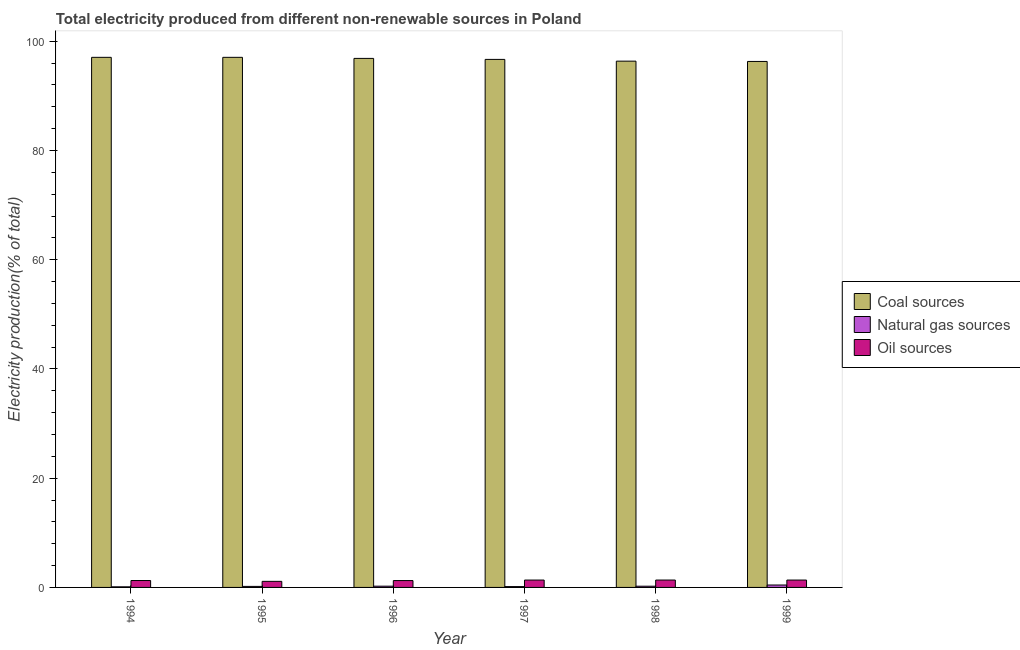How many different coloured bars are there?
Keep it short and to the point. 3. How many bars are there on the 2nd tick from the left?
Your answer should be compact. 3. How many bars are there on the 5th tick from the right?
Offer a terse response. 3. What is the label of the 5th group of bars from the left?
Offer a very short reply. 1998. What is the percentage of electricity produced by natural gas in 1998?
Your answer should be very brief. 0.22. Across all years, what is the maximum percentage of electricity produced by coal?
Give a very brief answer. 97.06. Across all years, what is the minimum percentage of electricity produced by coal?
Keep it short and to the point. 96.3. In which year was the percentage of electricity produced by coal minimum?
Your answer should be very brief. 1999. What is the total percentage of electricity produced by coal in the graph?
Provide a short and direct response. 580.32. What is the difference between the percentage of electricity produced by natural gas in 1995 and that in 1998?
Make the answer very short. -0.03. What is the difference between the percentage of electricity produced by oil sources in 1999 and the percentage of electricity produced by coal in 1998?
Provide a short and direct response. -0. What is the average percentage of electricity produced by natural gas per year?
Provide a short and direct response. 0.22. In the year 1997, what is the difference between the percentage of electricity produced by natural gas and percentage of electricity produced by oil sources?
Offer a very short reply. 0. In how many years, is the percentage of electricity produced by natural gas greater than 92 %?
Your response must be concise. 0. What is the ratio of the percentage of electricity produced by oil sources in 1994 to that in 1997?
Ensure brevity in your answer.  0.94. What is the difference between the highest and the second highest percentage of electricity produced by coal?
Make the answer very short. 0. What is the difference between the highest and the lowest percentage of electricity produced by oil sources?
Provide a short and direct response. 0.24. What does the 1st bar from the left in 1998 represents?
Provide a short and direct response. Coal sources. What does the 1st bar from the right in 1995 represents?
Give a very brief answer. Oil sources. Is it the case that in every year, the sum of the percentage of electricity produced by coal and percentage of electricity produced by natural gas is greater than the percentage of electricity produced by oil sources?
Make the answer very short. Yes. Are the values on the major ticks of Y-axis written in scientific E-notation?
Your response must be concise. No. Where does the legend appear in the graph?
Give a very brief answer. Center right. How are the legend labels stacked?
Your answer should be very brief. Vertical. What is the title of the graph?
Provide a succinct answer. Total electricity produced from different non-renewable sources in Poland. Does "Unemployment benefits" appear as one of the legend labels in the graph?
Make the answer very short. No. What is the label or title of the X-axis?
Offer a very short reply. Year. What is the Electricity production(% of total) in Coal sources in 1994?
Offer a very short reply. 97.06. What is the Electricity production(% of total) of Natural gas sources in 1994?
Ensure brevity in your answer.  0.11. What is the Electricity production(% of total) in Oil sources in 1994?
Provide a succinct answer. 1.26. What is the Electricity production(% of total) of Coal sources in 1995?
Offer a very short reply. 97.06. What is the Electricity production(% of total) in Natural gas sources in 1995?
Your answer should be compact. 0.19. What is the Electricity production(% of total) of Oil sources in 1995?
Your response must be concise. 1.11. What is the Electricity production(% of total) of Coal sources in 1996?
Your response must be concise. 96.86. What is the Electricity production(% of total) of Natural gas sources in 1996?
Your answer should be very brief. 0.23. What is the Electricity production(% of total) of Oil sources in 1996?
Your response must be concise. 1.26. What is the Electricity production(% of total) in Coal sources in 1997?
Offer a very short reply. 96.68. What is the Electricity production(% of total) in Natural gas sources in 1997?
Your response must be concise. 0.15. What is the Electricity production(% of total) in Oil sources in 1997?
Your response must be concise. 1.35. What is the Electricity production(% of total) of Coal sources in 1998?
Offer a terse response. 96.36. What is the Electricity production(% of total) in Natural gas sources in 1998?
Your response must be concise. 0.22. What is the Electricity production(% of total) in Oil sources in 1998?
Provide a succinct answer. 1.35. What is the Electricity production(% of total) in Coal sources in 1999?
Keep it short and to the point. 96.3. What is the Electricity production(% of total) of Natural gas sources in 1999?
Your response must be concise. 0.44. What is the Electricity production(% of total) of Oil sources in 1999?
Your answer should be compact. 1.35. Across all years, what is the maximum Electricity production(% of total) of Coal sources?
Provide a succinct answer. 97.06. Across all years, what is the maximum Electricity production(% of total) in Natural gas sources?
Give a very brief answer. 0.44. Across all years, what is the maximum Electricity production(% of total) of Oil sources?
Give a very brief answer. 1.35. Across all years, what is the minimum Electricity production(% of total) of Coal sources?
Provide a succinct answer. 96.3. Across all years, what is the minimum Electricity production(% of total) of Natural gas sources?
Offer a very short reply. 0.11. Across all years, what is the minimum Electricity production(% of total) in Oil sources?
Make the answer very short. 1.11. What is the total Electricity production(% of total) in Coal sources in the graph?
Keep it short and to the point. 580.32. What is the total Electricity production(% of total) of Natural gas sources in the graph?
Your response must be concise. 1.35. What is the total Electricity production(% of total) in Oil sources in the graph?
Your response must be concise. 7.68. What is the difference between the Electricity production(% of total) in Coal sources in 1994 and that in 1995?
Your answer should be compact. -0. What is the difference between the Electricity production(% of total) in Natural gas sources in 1994 and that in 1995?
Keep it short and to the point. -0.08. What is the difference between the Electricity production(% of total) in Oil sources in 1994 and that in 1995?
Offer a very short reply. 0.15. What is the difference between the Electricity production(% of total) in Coal sources in 1994 and that in 1996?
Your response must be concise. 0.19. What is the difference between the Electricity production(% of total) in Natural gas sources in 1994 and that in 1996?
Offer a very short reply. -0.12. What is the difference between the Electricity production(% of total) in Oil sources in 1994 and that in 1996?
Your response must be concise. 0.01. What is the difference between the Electricity production(% of total) in Coal sources in 1994 and that in 1997?
Offer a very short reply. 0.38. What is the difference between the Electricity production(% of total) in Natural gas sources in 1994 and that in 1997?
Ensure brevity in your answer.  -0.04. What is the difference between the Electricity production(% of total) in Oil sources in 1994 and that in 1997?
Your answer should be compact. -0.08. What is the difference between the Electricity production(% of total) of Coal sources in 1994 and that in 1998?
Your answer should be very brief. 0.7. What is the difference between the Electricity production(% of total) in Natural gas sources in 1994 and that in 1998?
Provide a succinct answer. -0.11. What is the difference between the Electricity production(% of total) of Oil sources in 1994 and that in 1998?
Your answer should be compact. -0.09. What is the difference between the Electricity production(% of total) of Coal sources in 1994 and that in 1999?
Your response must be concise. 0.75. What is the difference between the Electricity production(% of total) of Natural gas sources in 1994 and that in 1999?
Ensure brevity in your answer.  -0.33. What is the difference between the Electricity production(% of total) in Oil sources in 1994 and that in 1999?
Offer a very short reply. -0.09. What is the difference between the Electricity production(% of total) of Coal sources in 1995 and that in 1996?
Your response must be concise. 0.19. What is the difference between the Electricity production(% of total) of Natural gas sources in 1995 and that in 1996?
Offer a terse response. -0.04. What is the difference between the Electricity production(% of total) in Oil sources in 1995 and that in 1996?
Provide a short and direct response. -0.14. What is the difference between the Electricity production(% of total) in Coal sources in 1995 and that in 1997?
Your answer should be very brief. 0.38. What is the difference between the Electricity production(% of total) in Natural gas sources in 1995 and that in 1997?
Keep it short and to the point. 0.04. What is the difference between the Electricity production(% of total) of Oil sources in 1995 and that in 1997?
Provide a short and direct response. -0.24. What is the difference between the Electricity production(% of total) in Coal sources in 1995 and that in 1998?
Offer a terse response. 0.7. What is the difference between the Electricity production(% of total) in Natural gas sources in 1995 and that in 1998?
Keep it short and to the point. -0.03. What is the difference between the Electricity production(% of total) of Oil sources in 1995 and that in 1998?
Your response must be concise. -0.24. What is the difference between the Electricity production(% of total) of Coal sources in 1995 and that in 1999?
Provide a succinct answer. 0.75. What is the difference between the Electricity production(% of total) in Natural gas sources in 1995 and that in 1999?
Your answer should be compact. -0.25. What is the difference between the Electricity production(% of total) in Oil sources in 1995 and that in 1999?
Offer a very short reply. -0.24. What is the difference between the Electricity production(% of total) of Coal sources in 1996 and that in 1997?
Provide a short and direct response. 0.18. What is the difference between the Electricity production(% of total) of Natural gas sources in 1996 and that in 1997?
Ensure brevity in your answer.  0.08. What is the difference between the Electricity production(% of total) of Oil sources in 1996 and that in 1997?
Provide a succinct answer. -0.09. What is the difference between the Electricity production(% of total) of Coal sources in 1996 and that in 1998?
Keep it short and to the point. 0.5. What is the difference between the Electricity production(% of total) in Natural gas sources in 1996 and that in 1998?
Your response must be concise. 0.01. What is the difference between the Electricity production(% of total) in Oil sources in 1996 and that in 1998?
Make the answer very short. -0.1. What is the difference between the Electricity production(% of total) in Coal sources in 1996 and that in 1999?
Ensure brevity in your answer.  0.56. What is the difference between the Electricity production(% of total) in Natural gas sources in 1996 and that in 1999?
Offer a terse response. -0.21. What is the difference between the Electricity production(% of total) in Oil sources in 1996 and that in 1999?
Give a very brief answer. -0.1. What is the difference between the Electricity production(% of total) of Coal sources in 1997 and that in 1998?
Make the answer very short. 0.32. What is the difference between the Electricity production(% of total) in Natural gas sources in 1997 and that in 1998?
Ensure brevity in your answer.  -0.07. What is the difference between the Electricity production(% of total) in Oil sources in 1997 and that in 1998?
Your answer should be compact. -0. What is the difference between the Electricity production(% of total) in Natural gas sources in 1997 and that in 1999?
Your answer should be very brief. -0.29. What is the difference between the Electricity production(% of total) of Oil sources in 1997 and that in 1999?
Offer a very short reply. -0. What is the difference between the Electricity production(% of total) of Coal sources in 1998 and that in 1999?
Keep it short and to the point. 0.06. What is the difference between the Electricity production(% of total) of Natural gas sources in 1998 and that in 1999?
Provide a short and direct response. -0.22. What is the difference between the Electricity production(% of total) in Oil sources in 1998 and that in 1999?
Keep it short and to the point. 0. What is the difference between the Electricity production(% of total) in Coal sources in 1994 and the Electricity production(% of total) in Natural gas sources in 1995?
Your response must be concise. 96.87. What is the difference between the Electricity production(% of total) in Coal sources in 1994 and the Electricity production(% of total) in Oil sources in 1995?
Offer a terse response. 95.95. What is the difference between the Electricity production(% of total) of Natural gas sources in 1994 and the Electricity production(% of total) of Oil sources in 1995?
Your answer should be very brief. -1. What is the difference between the Electricity production(% of total) in Coal sources in 1994 and the Electricity production(% of total) in Natural gas sources in 1996?
Offer a terse response. 96.83. What is the difference between the Electricity production(% of total) in Coal sources in 1994 and the Electricity production(% of total) in Oil sources in 1996?
Offer a very short reply. 95.8. What is the difference between the Electricity production(% of total) of Natural gas sources in 1994 and the Electricity production(% of total) of Oil sources in 1996?
Your response must be concise. -1.14. What is the difference between the Electricity production(% of total) in Coal sources in 1994 and the Electricity production(% of total) in Natural gas sources in 1997?
Your answer should be compact. 96.9. What is the difference between the Electricity production(% of total) in Coal sources in 1994 and the Electricity production(% of total) in Oil sources in 1997?
Provide a short and direct response. 95.71. What is the difference between the Electricity production(% of total) in Natural gas sources in 1994 and the Electricity production(% of total) in Oil sources in 1997?
Offer a very short reply. -1.24. What is the difference between the Electricity production(% of total) in Coal sources in 1994 and the Electricity production(% of total) in Natural gas sources in 1998?
Ensure brevity in your answer.  96.83. What is the difference between the Electricity production(% of total) in Coal sources in 1994 and the Electricity production(% of total) in Oil sources in 1998?
Give a very brief answer. 95.71. What is the difference between the Electricity production(% of total) of Natural gas sources in 1994 and the Electricity production(% of total) of Oil sources in 1998?
Offer a terse response. -1.24. What is the difference between the Electricity production(% of total) of Coal sources in 1994 and the Electricity production(% of total) of Natural gas sources in 1999?
Your response must be concise. 96.61. What is the difference between the Electricity production(% of total) in Coal sources in 1994 and the Electricity production(% of total) in Oil sources in 1999?
Your answer should be very brief. 95.71. What is the difference between the Electricity production(% of total) in Natural gas sources in 1994 and the Electricity production(% of total) in Oil sources in 1999?
Offer a terse response. -1.24. What is the difference between the Electricity production(% of total) in Coal sources in 1995 and the Electricity production(% of total) in Natural gas sources in 1996?
Make the answer very short. 96.83. What is the difference between the Electricity production(% of total) in Coal sources in 1995 and the Electricity production(% of total) in Oil sources in 1996?
Your answer should be compact. 95.8. What is the difference between the Electricity production(% of total) in Natural gas sources in 1995 and the Electricity production(% of total) in Oil sources in 1996?
Offer a terse response. -1.07. What is the difference between the Electricity production(% of total) in Coal sources in 1995 and the Electricity production(% of total) in Natural gas sources in 1997?
Keep it short and to the point. 96.9. What is the difference between the Electricity production(% of total) in Coal sources in 1995 and the Electricity production(% of total) in Oil sources in 1997?
Make the answer very short. 95.71. What is the difference between the Electricity production(% of total) in Natural gas sources in 1995 and the Electricity production(% of total) in Oil sources in 1997?
Ensure brevity in your answer.  -1.16. What is the difference between the Electricity production(% of total) in Coal sources in 1995 and the Electricity production(% of total) in Natural gas sources in 1998?
Keep it short and to the point. 96.83. What is the difference between the Electricity production(% of total) of Coal sources in 1995 and the Electricity production(% of total) of Oil sources in 1998?
Offer a terse response. 95.71. What is the difference between the Electricity production(% of total) of Natural gas sources in 1995 and the Electricity production(% of total) of Oil sources in 1998?
Keep it short and to the point. -1.16. What is the difference between the Electricity production(% of total) in Coal sources in 1995 and the Electricity production(% of total) in Natural gas sources in 1999?
Ensure brevity in your answer.  96.61. What is the difference between the Electricity production(% of total) of Coal sources in 1995 and the Electricity production(% of total) of Oil sources in 1999?
Keep it short and to the point. 95.71. What is the difference between the Electricity production(% of total) of Natural gas sources in 1995 and the Electricity production(% of total) of Oil sources in 1999?
Offer a terse response. -1.16. What is the difference between the Electricity production(% of total) of Coal sources in 1996 and the Electricity production(% of total) of Natural gas sources in 1997?
Offer a very short reply. 96.71. What is the difference between the Electricity production(% of total) of Coal sources in 1996 and the Electricity production(% of total) of Oil sources in 1997?
Ensure brevity in your answer.  95.51. What is the difference between the Electricity production(% of total) of Natural gas sources in 1996 and the Electricity production(% of total) of Oil sources in 1997?
Your answer should be compact. -1.12. What is the difference between the Electricity production(% of total) in Coal sources in 1996 and the Electricity production(% of total) in Natural gas sources in 1998?
Provide a short and direct response. 96.64. What is the difference between the Electricity production(% of total) of Coal sources in 1996 and the Electricity production(% of total) of Oil sources in 1998?
Your response must be concise. 95.51. What is the difference between the Electricity production(% of total) of Natural gas sources in 1996 and the Electricity production(% of total) of Oil sources in 1998?
Ensure brevity in your answer.  -1.12. What is the difference between the Electricity production(% of total) in Coal sources in 1996 and the Electricity production(% of total) in Natural gas sources in 1999?
Offer a very short reply. 96.42. What is the difference between the Electricity production(% of total) in Coal sources in 1996 and the Electricity production(% of total) in Oil sources in 1999?
Your answer should be compact. 95.51. What is the difference between the Electricity production(% of total) in Natural gas sources in 1996 and the Electricity production(% of total) in Oil sources in 1999?
Your answer should be very brief. -1.12. What is the difference between the Electricity production(% of total) of Coal sources in 1997 and the Electricity production(% of total) of Natural gas sources in 1998?
Keep it short and to the point. 96.46. What is the difference between the Electricity production(% of total) of Coal sources in 1997 and the Electricity production(% of total) of Oil sources in 1998?
Offer a terse response. 95.33. What is the difference between the Electricity production(% of total) of Natural gas sources in 1997 and the Electricity production(% of total) of Oil sources in 1998?
Ensure brevity in your answer.  -1.2. What is the difference between the Electricity production(% of total) of Coal sources in 1997 and the Electricity production(% of total) of Natural gas sources in 1999?
Make the answer very short. 96.23. What is the difference between the Electricity production(% of total) in Coal sources in 1997 and the Electricity production(% of total) in Oil sources in 1999?
Give a very brief answer. 95.33. What is the difference between the Electricity production(% of total) of Natural gas sources in 1997 and the Electricity production(% of total) of Oil sources in 1999?
Make the answer very short. -1.2. What is the difference between the Electricity production(% of total) of Coal sources in 1998 and the Electricity production(% of total) of Natural gas sources in 1999?
Ensure brevity in your answer.  95.92. What is the difference between the Electricity production(% of total) of Coal sources in 1998 and the Electricity production(% of total) of Oil sources in 1999?
Offer a very short reply. 95.01. What is the difference between the Electricity production(% of total) of Natural gas sources in 1998 and the Electricity production(% of total) of Oil sources in 1999?
Your answer should be very brief. -1.13. What is the average Electricity production(% of total) in Coal sources per year?
Ensure brevity in your answer.  96.72. What is the average Electricity production(% of total) in Natural gas sources per year?
Provide a short and direct response. 0.22. What is the average Electricity production(% of total) in Oil sources per year?
Make the answer very short. 1.28. In the year 1994, what is the difference between the Electricity production(% of total) in Coal sources and Electricity production(% of total) in Natural gas sources?
Offer a very short reply. 96.95. In the year 1994, what is the difference between the Electricity production(% of total) of Coal sources and Electricity production(% of total) of Oil sources?
Provide a short and direct response. 95.79. In the year 1994, what is the difference between the Electricity production(% of total) in Natural gas sources and Electricity production(% of total) in Oil sources?
Your answer should be very brief. -1.15. In the year 1995, what is the difference between the Electricity production(% of total) in Coal sources and Electricity production(% of total) in Natural gas sources?
Provide a short and direct response. 96.87. In the year 1995, what is the difference between the Electricity production(% of total) of Coal sources and Electricity production(% of total) of Oil sources?
Your answer should be compact. 95.95. In the year 1995, what is the difference between the Electricity production(% of total) in Natural gas sources and Electricity production(% of total) in Oil sources?
Your answer should be very brief. -0.92. In the year 1996, what is the difference between the Electricity production(% of total) in Coal sources and Electricity production(% of total) in Natural gas sources?
Your answer should be very brief. 96.63. In the year 1996, what is the difference between the Electricity production(% of total) of Coal sources and Electricity production(% of total) of Oil sources?
Keep it short and to the point. 95.61. In the year 1996, what is the difference between the Electricity production(% of total) of Natural gas sources and Electricity production(% of total) of Oil sources?
Your answer should be compact. -1.03. In the year 1997, what is the difference between the Electricity production(% of total) of Coal sources and Electricity production(% of total) of Natural gas sources?
Your answer should be very brief. 96.53. In the year 1997, what is the difference between the Electricity production(% of total) of Coal sources and Electricity production(% of total) of Oil sources?
Your response must be concise. 95.33. In the year 1997, what is the difference between the Electricity production(% of total) in Natural gas sources and Electricity production(% of total) in Oil sources?
Keep it short and to the point. -1.2. In the year 1998, what is the difference between the Electricity production(% of total) of Coal sources and Electricity production(% of total) of Natural gas sources?
Offer a very short reply. 96.14. In the year 1998, what is the difference between the Electricity production(% of total) in Coal sources and Electricity production(% of total) in Oil sources?
Provide a succinct answer. 95.01. In the year 1998, what is the difference between the Electricity production(% of total) of Natural gas sources and Electricity production(% of total) of Oil sources?
Your answer should be compact. -1.13. In the year 1999, what is the difference between the Electricity production(% of total) of Coal sources and Electricity production(% of total) of Natural gas sources?
Give a very brief answer. 95.86. In the year 1999, what is the difference between the Electricity production(% of total) in Coal sources and Electricity production(% of total) in Oil sources?
Keep it short and to the point. 94.95. In the year 1999, what is the difference between the Electricity production(% of total) in Natural gas sources and Electricity production(% of total) in Oil sources?
Provide a succinct answer. -0.91. What is the ratio of the Electricity production(% of total) in Coal sources in 1994 to that in 1995?
Give a very brief answer. 1. What is the ratio of the Electricity production(% of total) in Natural gas sources in 1994 to that in 1995?
Your answer should be compact. 0.59. What is the ratio of the Electricity production(% of total) in Oil sources in 1994 to that in 1995?
Give a very brief answer. 1.14. What is the ratio of the Electricity production(% of total) in Natural gas sources in 1994 to that in 1996?
Ensure brevity in your answer.  0.48. What is the ratio of the Electricity production(% of total) in Oil sources in 1994 to that in 1996?
Your answer should be very brief. 1.01. What is the ratio of the Electricity production(% of total) of Natural gas sources in 1994 to that in 1997?
Offer a very short reply. 0.72. What is the ratio of the Electricity production(% of total) of Oil sources in 1994 to that in 1997?
Give a very brief answer. 0.94. What is the ratio of the Electricity production(% of total) of Natural gas sources in 1994 to that in 1998?
Your answer should be compact. 0.5. What is the ratio of the Electricity production(% of total) in Oil sources in 1994 to that in 1998?
Give a very brief answer. 0.94. What is the ratio of the Electricity production(% of total) of Natural gas sources in 1994 to that in 1999?
Your response must be concise. 0.25. What is the ratio of the Electricity production(% of total) of Oil sources in 1994 to that in 1999?
Your answer should be very brief. 0.94. What is the ratio of the Electricity production(% of total) of Natural gas sources in 1995 to that in 1996?
Give a very brief answer. 0.82. What is the ratio of the Electricity production(% of total) in Oil sources in 1995 to that in 1996?
Make the answer very short. 0.89. What is the ratio of the Electricity production(% of total) of Natural gas sources in 1995 to that in 1997?
Your answer should be very brief. 1.23. What is the ratio of the Electricity production(% of total) in Oil sources in 1995 to that in 1997?
Your response must be concise. 0.82. What is the ratio of the Electricity production(% of total) in Natural gas sources in 1995 to that in 1998?
Your response must be concise. 0.85. What is the ratio of the Electricity production(% of total) of Oil sources in 1995 to that in 1998?
Offer a very short reply. 0.82. What is the ratio of the Electricity production(% of total) in Natural gas sources in 1995 to that in 1999?
Offer a very short reply. 0.43. What is the ratio of the Electricity production(% of total) of Oil sources in 1995 to that in 1999?
Give a very brief answer. 0.82. What is the ratio of the Electricity production(% of total) in Natural gas sources in 1996 to that in 1997?
Make the answer very short. 1.5. What is the ratio of the Electricity production(% of total) in Oil sources in 1996 to that in 1997?
Your answer should be compact. 0.93. What is the ratio of the Electricity production(% of total) of Natural gas sources in 1996 to that in 1998?
Provide a succinct answer. 1.03. What is the ratio of the Electricity production(% of total) of Oil sources in 1996 to that in 1998?
Make the answer very short. 0.93. What is the ratio of the Electricity production(% of total) in Coal sources in 1996 to that in 1999?
Your answer should be very brief. 1.01. What is the ratio of the Electricity production(% of total) in Natural gas sources in 1996 to that in 1999?
Offer a terse response. 0.52. What is the ratio of the Electricity production(% of total) of Oil sources in 1996 to that in 1999?
Your answer should be compact. 0.93. What is the ratio of the Electricity production(% of total) of Coal sources in 1997 to that in 1998?
Your answer should be very brief. 1. What is the ratio of the Electricity production(% of total) in Natural gas sources in 1997 to that in 1998?
Keep it short and to the point. 0.69. What is the ratio of the Electricity production(% of total) in Natural gas sources in 1997 to that in 1999?
Your answer should be compact. 0.34. What is the ratio of the Electricity production(% of total) in Oil sources in 1997 to that in 1999?
Your answer should be very brief. 1. What is the ratio of the Electricity production(% of total) in Natural gas sources in 1998 to that in 1999?
Your response must be concise. 0.5. What is the difference between the highest and the second highest Electricity production(% of total) of Coal sources?
Keep it short and to the point. 0. What is the difference between the highest and the second highest Electricity production(% of total) of Natural gas sources?
Your answer should be very brief. 0.21. What is the difference between the highest and the lowest Electricity production(% of total) in Coal sources?
Provide a succinct answer. 0.75. What is the difference between the highest and the lowest Electricity production(% of total) in Natural gas sources?
Keep it short and to the point. 0.33. What is the difference between the highest and the lowest Electricity production(% of total) of Oil sources?
Give a very brief answer. 0.24. 